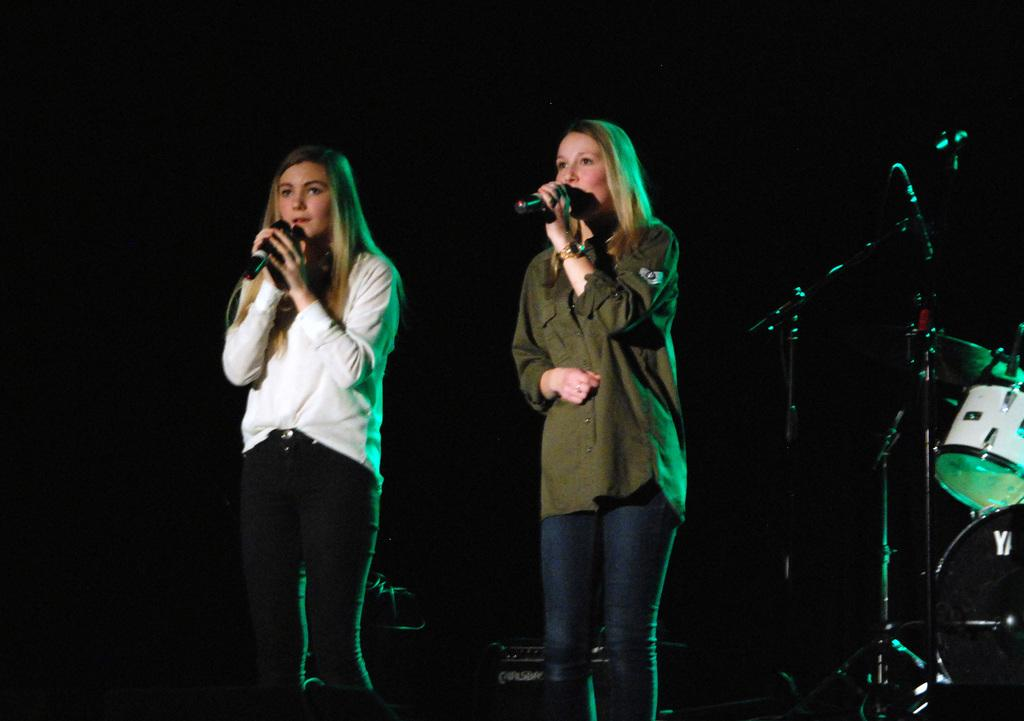How many women are present in the image? There are two women in the image. What are the women doing in the image? Both women are standing in the image. What objects are the women holding in their hands? Each woman is holding a microphone in her hand. What type of glue is being used by the women in the image? There is no glue present in the image; the women are holding microphones. What year is depicted in the image? The provided facts do not mention any specific year, so it cannot be determined from the image. 